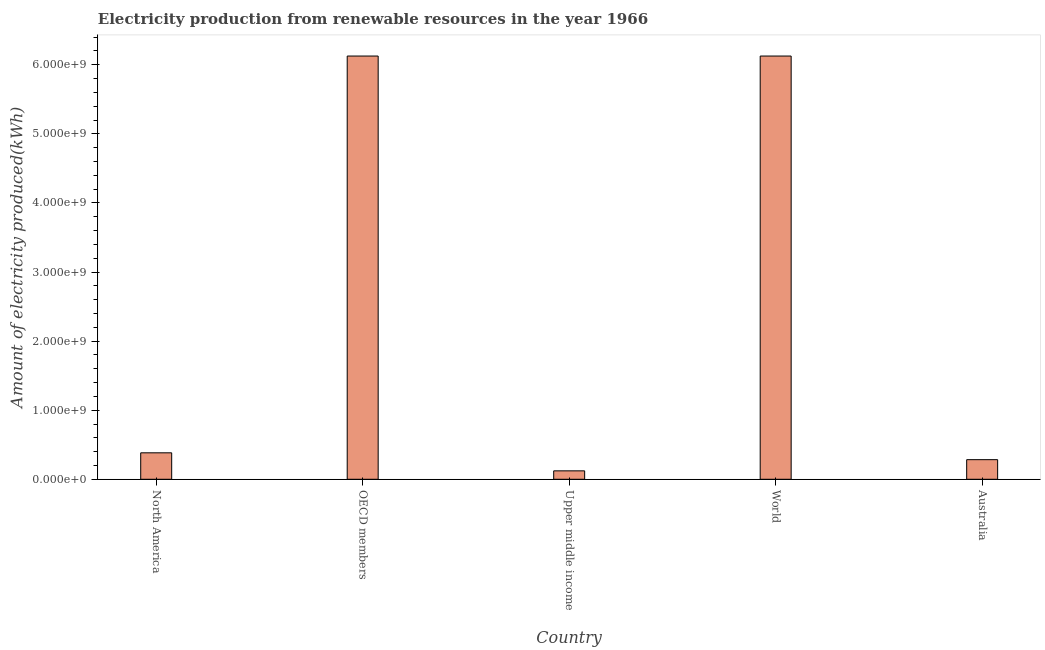What is the title of the graph?
Keep it short and to the point. Electricity production from renewable resources in the year 1966. What is the label or title of the X-axis?
Your answer should be very brief. Country. What is the label or title of the Y-axis?
Offer a terse response. Amount of electricity produced(kWh). What is the amount of electricity produced in OECD members?
Your answer should be compact. 6.13e+09. Across all countries, what is the maximum amount of electricity produced?
Your answer should be very brief. 6.13e+09. Across all countries, what is the minimum amount of electricity produced?
Your response must be concise. 1.22e+08. In which country was the amount of electricity produced minimum?
Your answer should be very brief. Upper middle income. What is the sum of the amount of electricity produced?
Offer a terse response. 1.30e+1. What is the average amount of electricity produced per country?
Your answer should be very brief. 2.61e+09. What is the median amount of electricity produced?
Offer a very short reply. 3.83e+08. What is the ratio of the amount of electricity produced in Australia to that in North America?
Offer a terse response. 0.74. Is the amount of electricity produced in North America less than that in OECD members?
Offer a terse response. Yes. Is the sum of the amount of electricity produced in North America and World greater than the maximum amount of electricity produced across all countries?
Provide a succinct answer. Yes. What is the difference between the highest and the lowest amount of electricity produced?
Your answer should be very brief. 6.00e+09. How many bars are there?
Offer a very short reply. 5. Are all the bars in the graph horizontal?
Provide a short and direct response. No. What is the difference between two consecutive major ticks on the Y-axis?
Offer a terse response. 1.00e+09. Are the values on the major ticks of Y-axis written in scientific E-notation?
Offer a terse response. Yes. What is the Amount of electricity produced(kWh) in North America?
Your response must be concise. 3.83e+08. What is the Amount of electricity produced(kWh) of OECD members?
Your answer should be compact. 6.13e+09. What is the Amount of electricity produced(kWh) of Upper middle income?
Give a very brief answer. 1.22e+08. What is the Amount of electricity produced(kWh) in World?
Provide a succinct answer. 6.13e+09. What is the Amount of electricity produced(kWh) of Australia?
Ensure brevity in your answer.  2.84e+08. What is the difference between the Amount of electricity produced(kWh) in North America and OECD members?
Offer a terse response. -5.74e+09. What is the difference between the Amount of electricity produced(kWh) in North America and Upper middle income?
Give a very brief answer. 2.61e+08. What is the difference between the Amount of electricity produced(kWh) in North America and World?
Your response must be concise. -5.74e+09. What is the difference between the Amount of electricity produced(kWh) in North America and Australia?
Your answer should be very brief. 9.90e+07. What is the difference between the Amount of electricity produced(kWh) in OECD members and Upper middle income?
Keep it short and to the point. 6.00e+09. What is the difference between the Amount of electricity produced(kWh) in OECD members and World?
Offer a very short reply. 0. What is the difference between the Amount of electricity produced(kWh) in OECD members and Australia?
Ensure brevity in your answer.  5.84e+09. What is the difference between the Amount of electricity produced(kWh) in Upper middle income and World?
Make the answer very short. -6.00e+09. What is the difference between the Amount of electricity produced(kWh) in Upper middle income and Australia?
Offer a terse response. -1.62e+08. What is the difference between the Amount of electricity produced(kWh) in World and Australia?
Your answer should be compact. 5.84e+09. What is the ratio of the Amount of electricity produced(kWh) in North America to that in OECD members?
Offer a very short reply. 0.06. What is the ratio of the Amount of electricity produced(kWh) in North America to that in Upper middle income?
Offer a terse response. 3.14. What is the ratio of the Amount of electricity produced(kWh) in North America to that in World?
Your answer should be compact. 0.06. What is the ratio of the Amount of electricity produced(kWh) in North America to that in Australia?
Give a very brief answer. 1.35. What is the ratio of the Amount of electricity produced(kWh) in OECD members to that in Upper middle income?
Keep it short and to the point. 50.22. What is the ratio of the Amount of electricity produced(kWh) in OECD members to that in World?
Offer a terse response. 1. What is the ratio of the Amount of electricity produced(kWh) in OECD members to that in Australia?
Provide a succinct answer. 21.57. What is the ratio of the Amount of electricity produced(kWh) in Upper middle income to that in World?
Provide a short and direct response. 0.02. What is the ratio of the Amount of electricity produced(kWh) in Upper middle income to that in Australia?
Offer a terse response. 0.43. What is the ratio of the Amount of electricity produced(kWh) in World to that in Australia?
Make the answer very short. 21.57. 